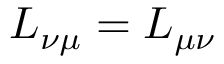Convert formula to latex. <formula><loc_0><loc_0><loc_500><loc_500>L _ { \nu \mu } = L _ { \mu \nu }</formula> 